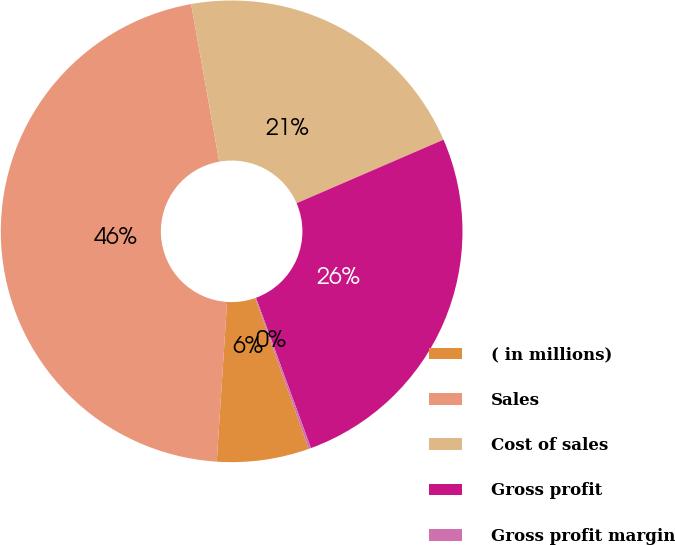<chart> <loc_0><loc_0><loc_500><loc_500><pie_chart><fcel>( in millions)<fcel>Sales<fcel>Cost of sales<fcel>Gross profit<fcel>Gross profit margin<nl><fcel>6.44%<fcel>46.16%<fcel>21.31%<fcel>25.91%<fcel>0.17%<nl></chart> 